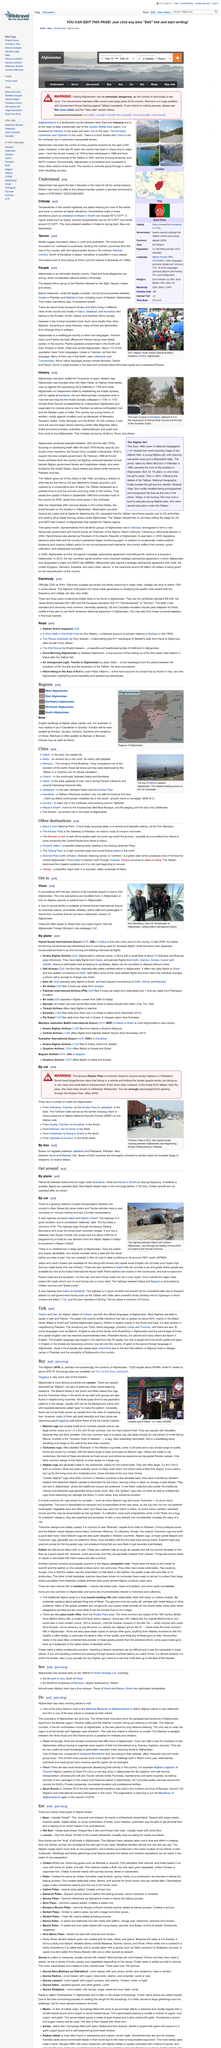Point out several critical features in this image. Pashto is spoken by both Afghanistan and Pakistan. The article primarily centers on the climate and terrain of Afghanistan. The Baloch tribe in Afghanistan is renowned for creating exquisite rugs that are simple in design but of extraordinary beauty. The most pleasant weather can be experienced in Kabul during the months of April, May, and September. Afghanistan is home to a diverse range of ethnic groups, including the Pashtun, Tajik, Hazara, Uzbek, and Baloch tribes. Each group has its own unique culture, language, and way of life. 